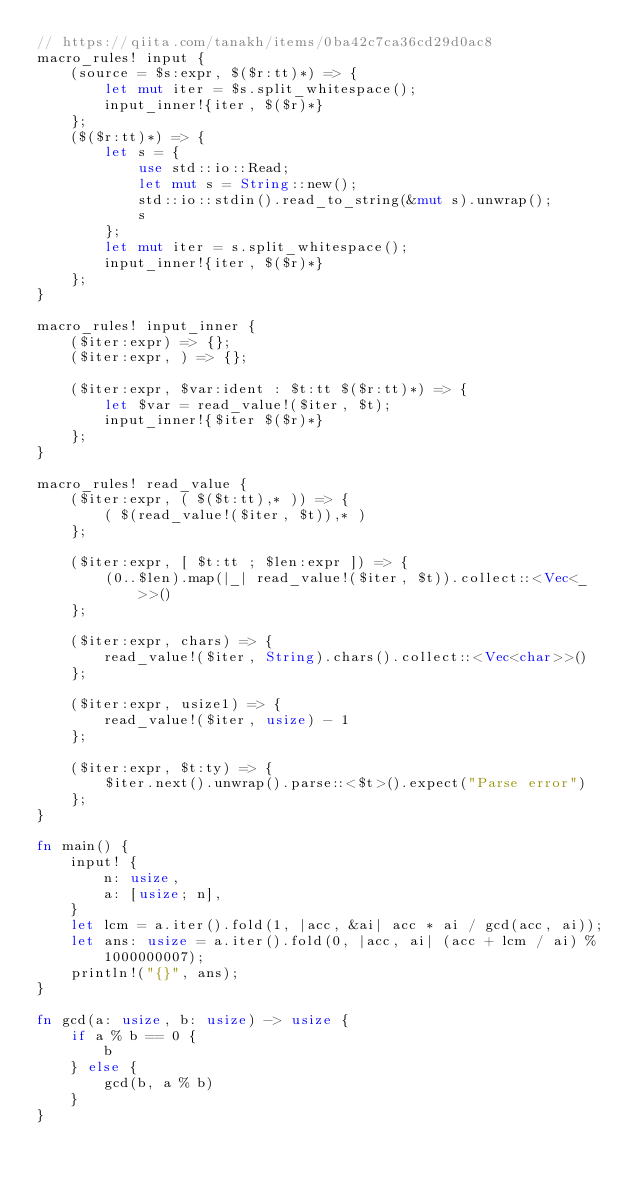Convert code to text. <code><loc_0><loc_0><loc_500><loc_500><_Rust_>// https://qiita.com/tanakh/items/0ba42c7ca36cd29d0ac8
macro_rules! input {
    (source = $s:expr, $($r:tt)*) => {
        let mut iter = $s.split_whitespace();
        input_inner!{iter, $($r)*}
    };
    ($($r:tt)*) => {
        let s = {
            use std::io::Read;
            let mut s = String::new();
            std::io::stdin().read_to_string(&mut s).unwrap();
            s
        };
        let mut iter = s.split_whitespace();
        input_inner!{iter, $($r)*}
    };
}

macro_rules! input_inner {
    ($iter:expr) => {};
    ($iter:expr, ) => {};

    ($iter:expr, $var:ident : $t:tt $($r:tt)*) => {
        let $var = read_value!($iter, $t);
        input_inner!{$iter $($r)*}
    };
}

macro_rules! read_value {
    ($iter:expr, ( $($t:tt),* )) => {
        ( $(read_value!($iter, $t)),* )
    };

    ($iter:expr, [ $t:tt ; $len:expr ]) => {
        (0..$len).map(|_| read_value!($iter, $t)).collect::<Vec<_>>()
    };

    ($iter:expr, chars) => {
        read_value!($iter, String).chars().collect::<Vec<char>>()
    };

    ($iter:expr, usize1) => {
        read_value!($iter, usize) - 1
    };

    ($iter:expr, $t:ty) => {
        $iter.next().unwrap().parse::<$t>().expect("Parse error")
    };
}

fn main() {
    input! {
        n: usize,
        a: [usize; n],
    }
    let lcm = a.iter().fold(1, |acc, &ai| acc * ai / gcd(acc, ai));
    let ans: usize = a.iter().fold(0, |acc, ai| (acc + lcm / ai) % 1000000007);
    println!("{}", ans);
}

fn gcd(a: usize, b: usize) -> usize {
    if a % b == 0 {
        b
    } else {
        gcd(b, a % b)
    }
}
</code> 